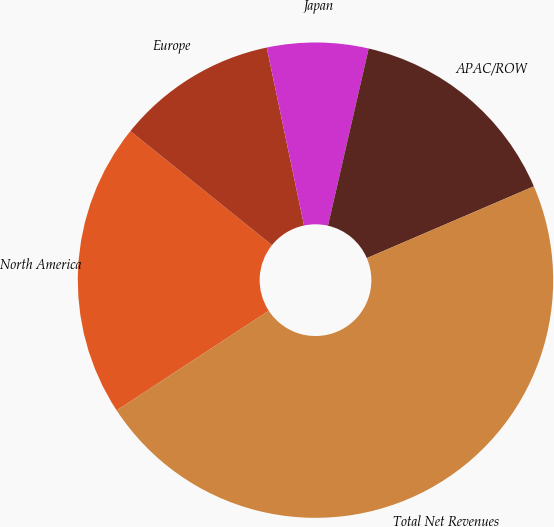Convert chart to OTSL. <chart><loc_0><loc_0><loc_500><loc_500><pie_chart><fcel>North America<fcel>Europe<fcel>Japan<fcel>APAC/ROW<fcel>Total Net Revenues<nl><fcel>20.02%<fcel>10.92%<fcel>6.88%<fcel>14.95%<fcel>47.23%<nl></chart> 